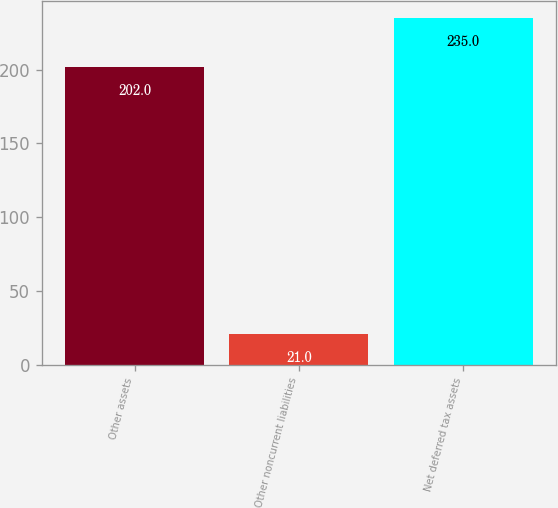Convert chart to OTSL. <chart><loc_0><loc_0><loc_500><loc_500><bar_chart><fcel>Other assets<fcel>Other noncurrent liabilities<fcel>Net deferred tax assets<nl><fcel>202<fcel>21<fcel>235<nl></chart> 